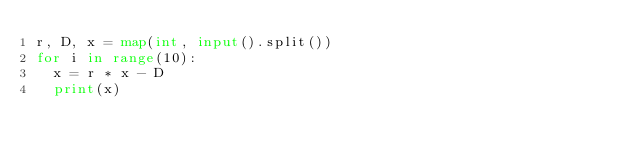<code> <loc_0><loc_0><loc_500><loc_500><_Python_>r, D, x = map(int, input().split())
for i in range(10):
  x = r * x - D
  print(x)</code> 